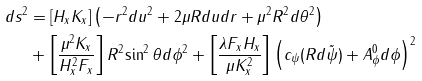<formula> <loc_0><loc_0><loc_500><loc_500>d s ^ { 2 } & = [ H _ { x } K _ { x } ] \left ( - { r ^ { 2 } d u ^ { 2 } } + { 2 \mu R d u d r } + \mu ^ { 2 } R ^ { 2 } { d \theta ^ { 2 } } \right ) \\ & + \left [ \frac { \mu ^ { 2 } K _ { x } } { H ^ { 2 } _ { x } F _ { x } } \right ] R ^ { 2 } { \sin ^ { 2 } \theta } d \phi ^ { 2 } + \left [ \frac { \lambda F _ { x } H _ { x } } { \mu K ^ { 2 } _ { x } } \right ] \left ( c _ { \psi } ( R d \tilde { \psi } ) + A ^ { 0 } _ { \phi } d \phi \right ) ^ { 2 }</formula> 